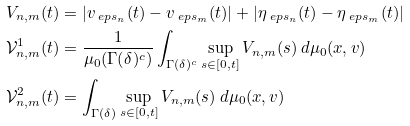<formula> <loc_0><loc_0><loc_500><loc_500>V _ { n , m } ( t ) & = | v _ { \ e p s _ { n } } ( t ) - v _ { \ e p s _ { m } } ( t ) | + | \eta _ { \ e p s _ { n } } ( t ) - \eta _ { \ e p s _ { m } } ( t ) | \\ \mathcal { V } _ { n , m } ^ { 1 } ( t ) & = \frac { 1 } { \mu _ { 0 } ( \Gamma ( \delta ) ^ { c } ) } \int _ { \Gamma ( \delta ) ^ { c } } \sup _ { s \in [ 0 , t ] } V _ { n , m } ( s ) \ d \mu _ { 0 } ( x , v ) \\ \mathcal { V } _ { n , m } ^ { 2 } ( t ) & = \int _ { \Gamma ( \delta ) } \sup _ { s \in [ 0 , t ] } V _ { n , m } ( s ) \ d \mu _ { 0 } ( x , v )</formula> 